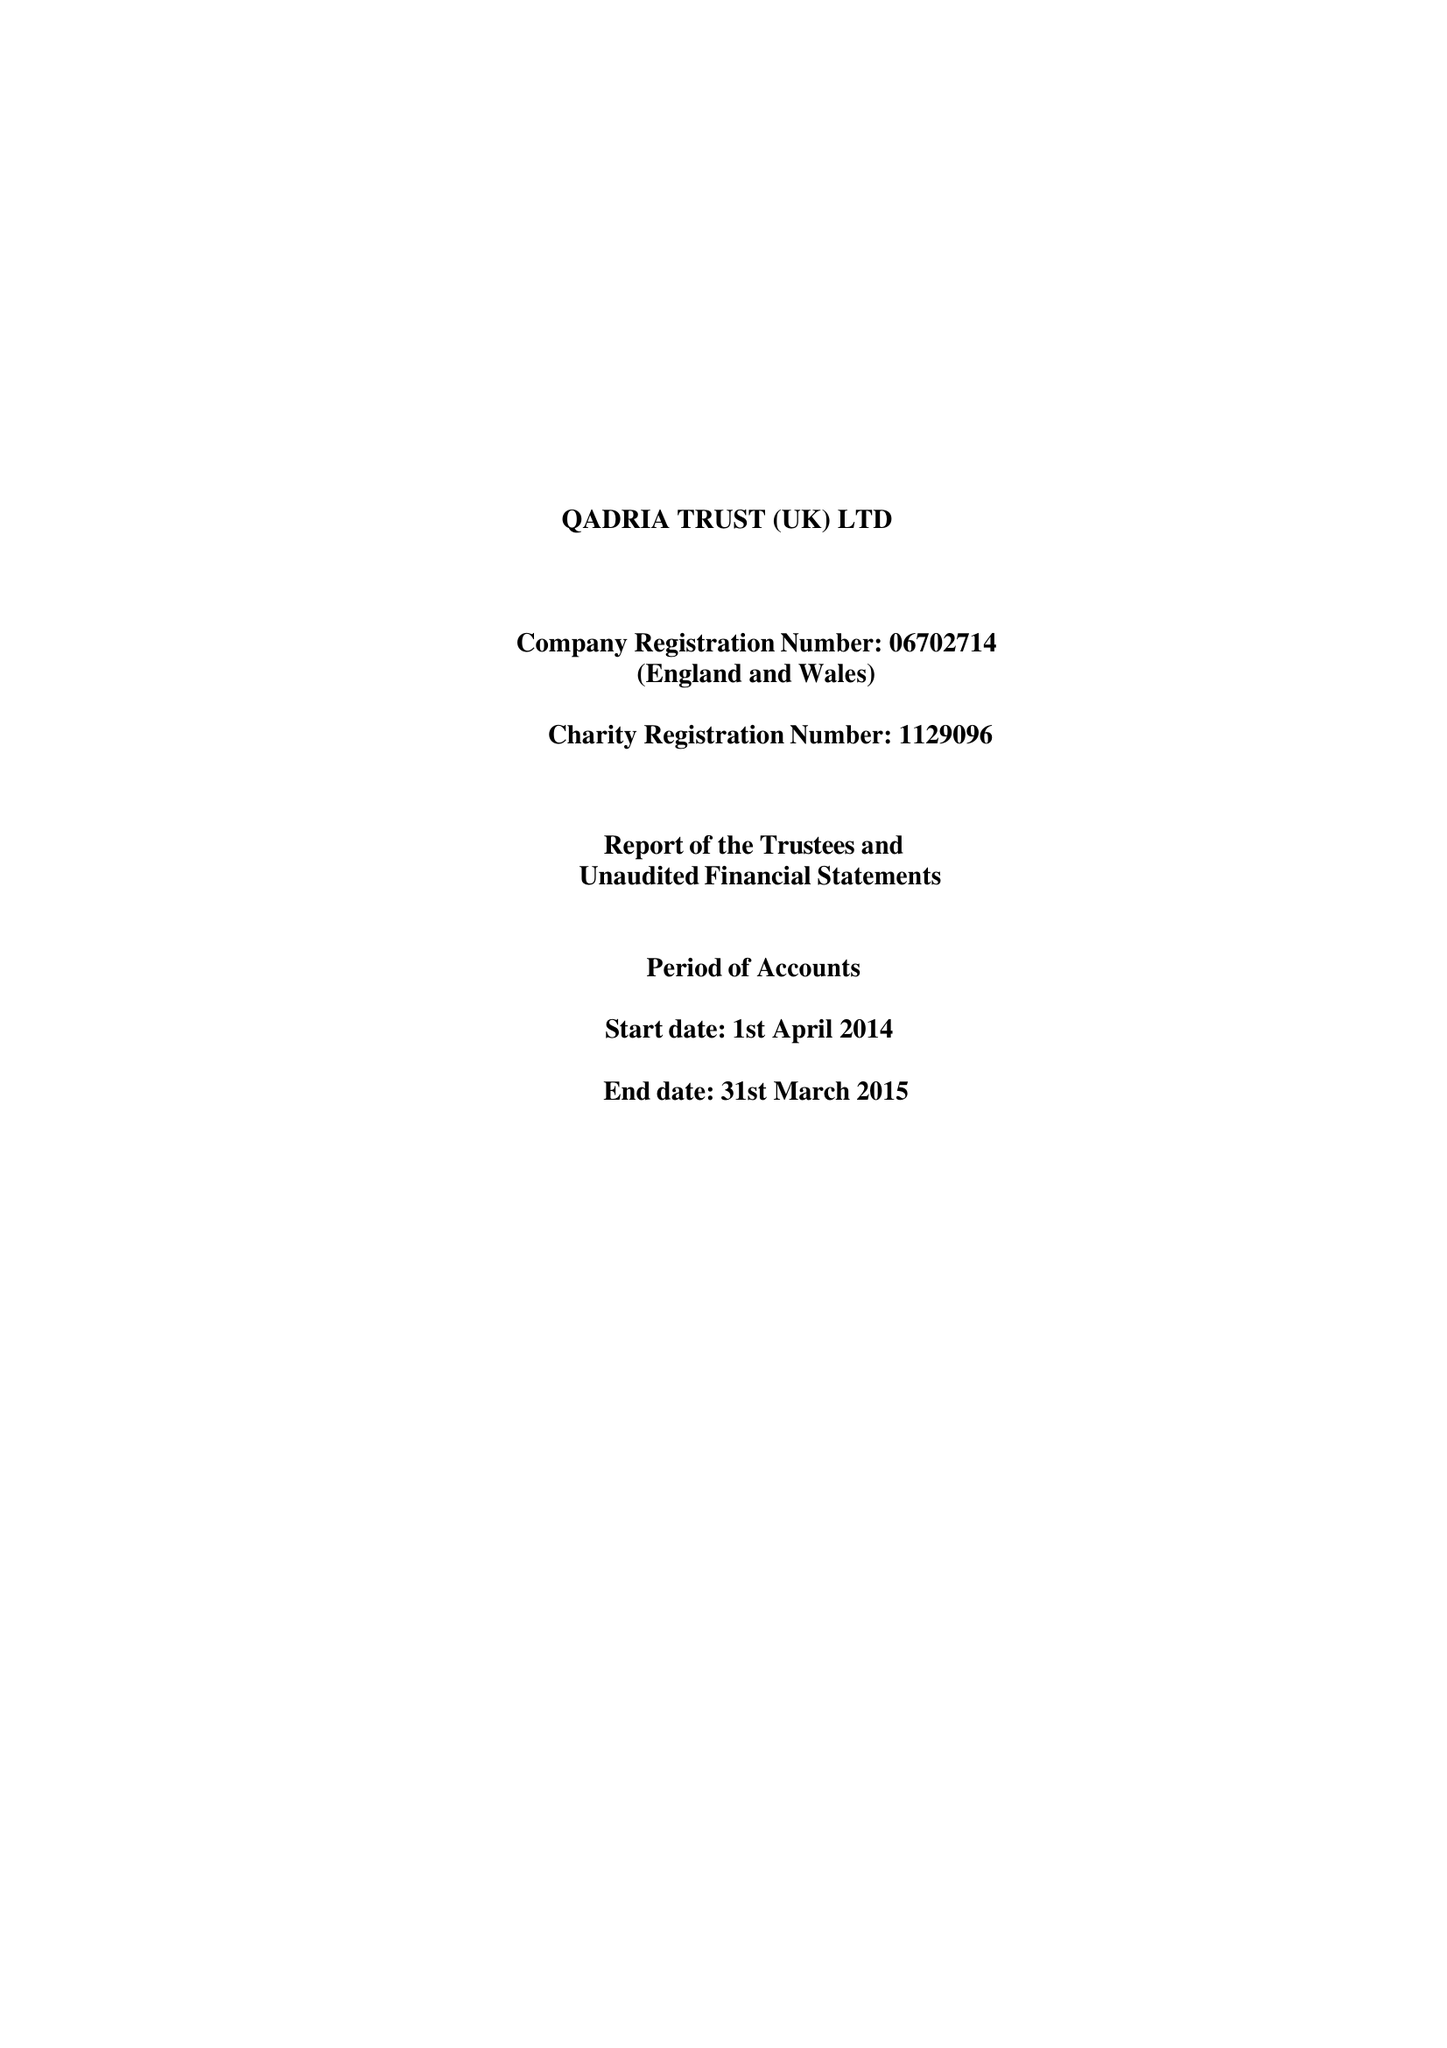What is the value for the address__street_line?
Answer the question using a single word or phrase. 26 ALFRED STREET 